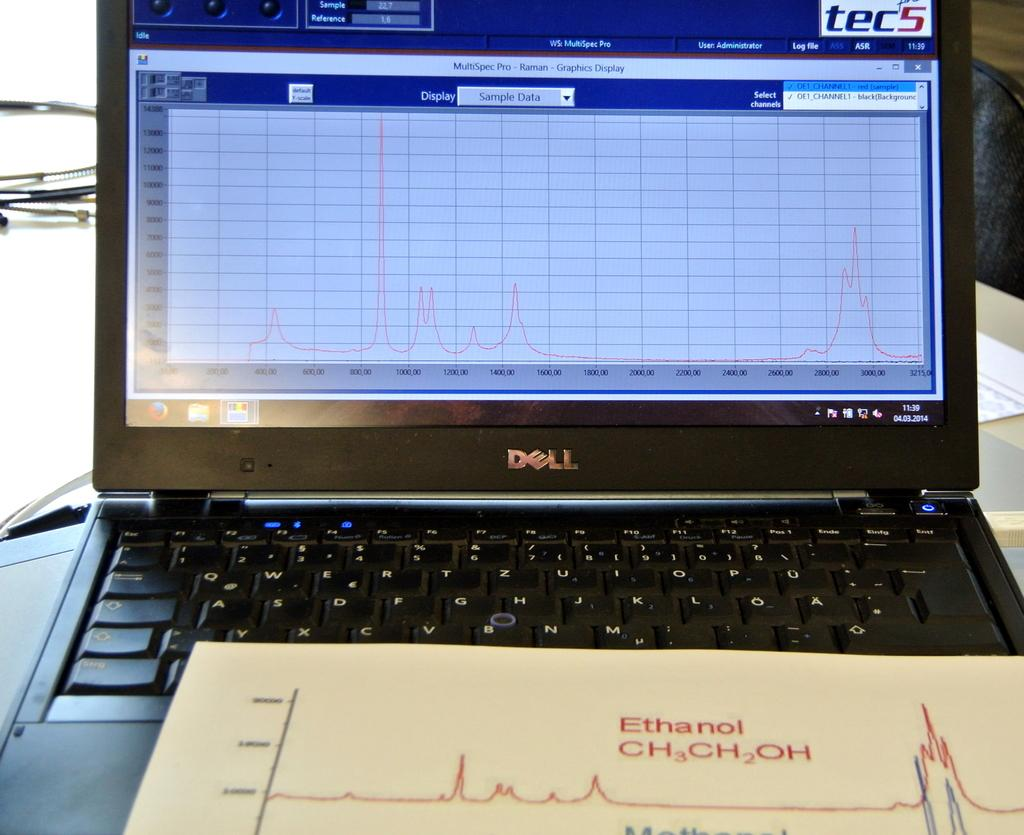<image>
Provide a brief description of the given image. A black laptop says Dell on the front. 